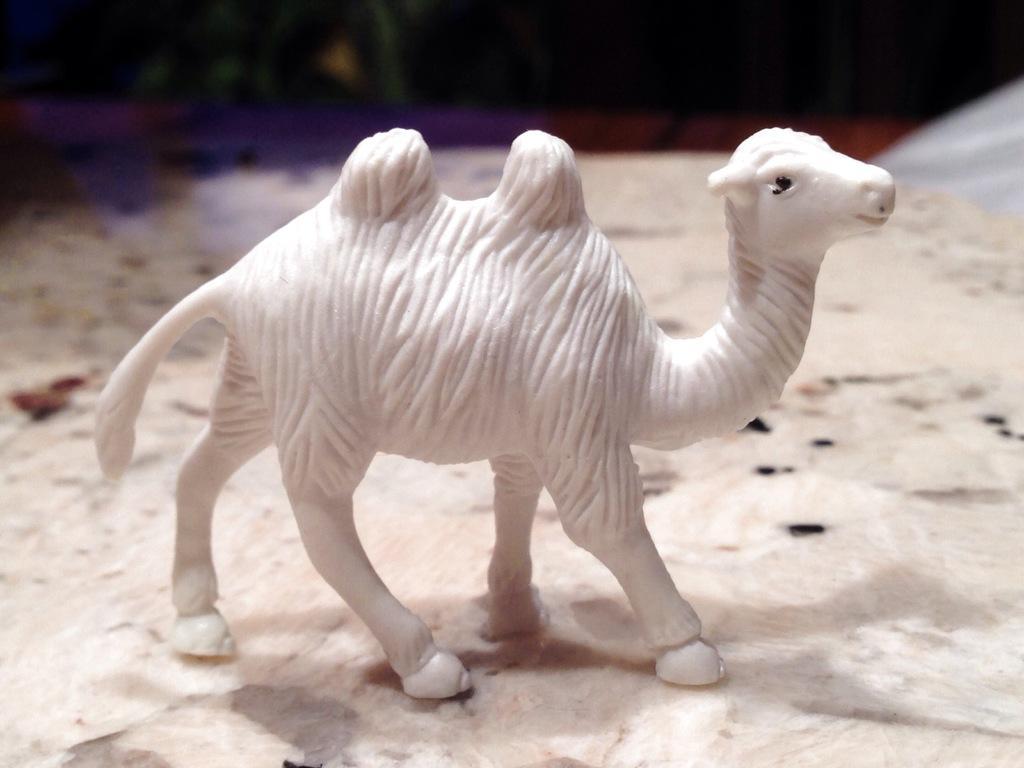In one or two sentences, can you explain what this image depicts? In this image I can see a toy of an animal on a white surface. This toy is in white color. The background is blurred. 